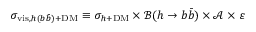Convert formula to latex. <formula><loc_0><loc_0><loc_500><loc_500>\sigma _ { v i s , h ( b \bar { b } ) + D M } \equiv \sigma _ { h + D M } \times \ m a t h s c r { B } ( h \to b \bar { b } ) \times \ m a t h s c r { A } \times \varepsilon</formula> 